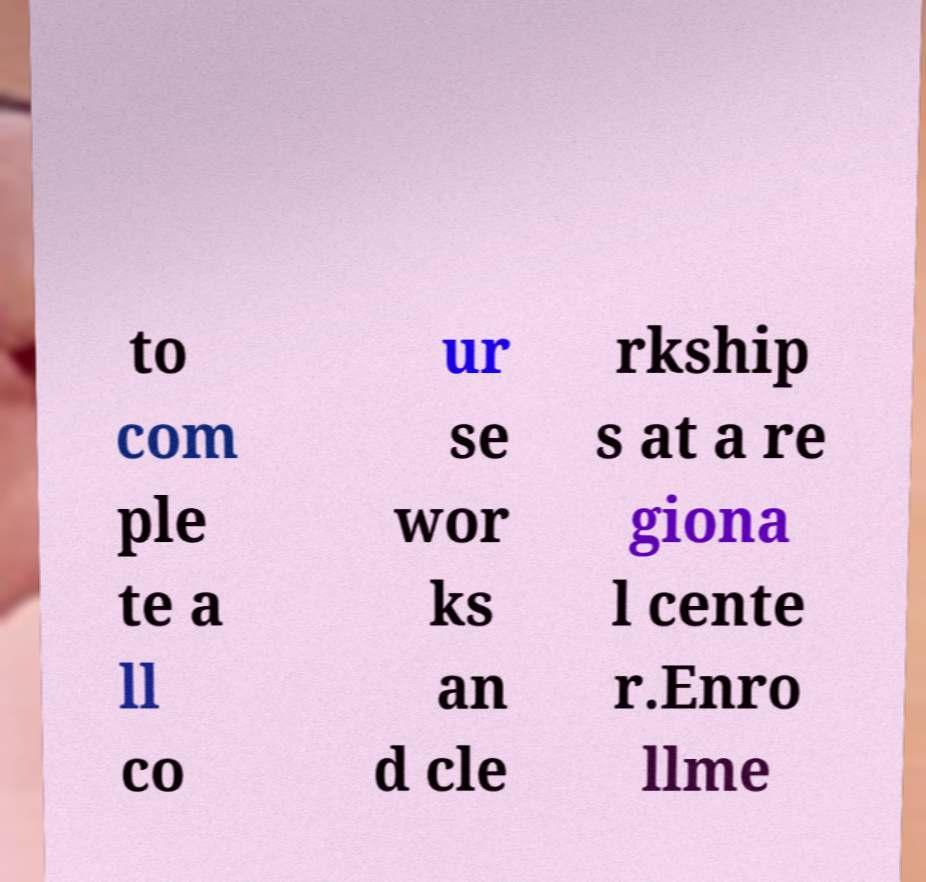What messages or text are displayed in this image? I need them in a readable, typed format. to com ple te a ll co ur se wor ks an d cle rkship s at a re giona l cente r.Enro llme 